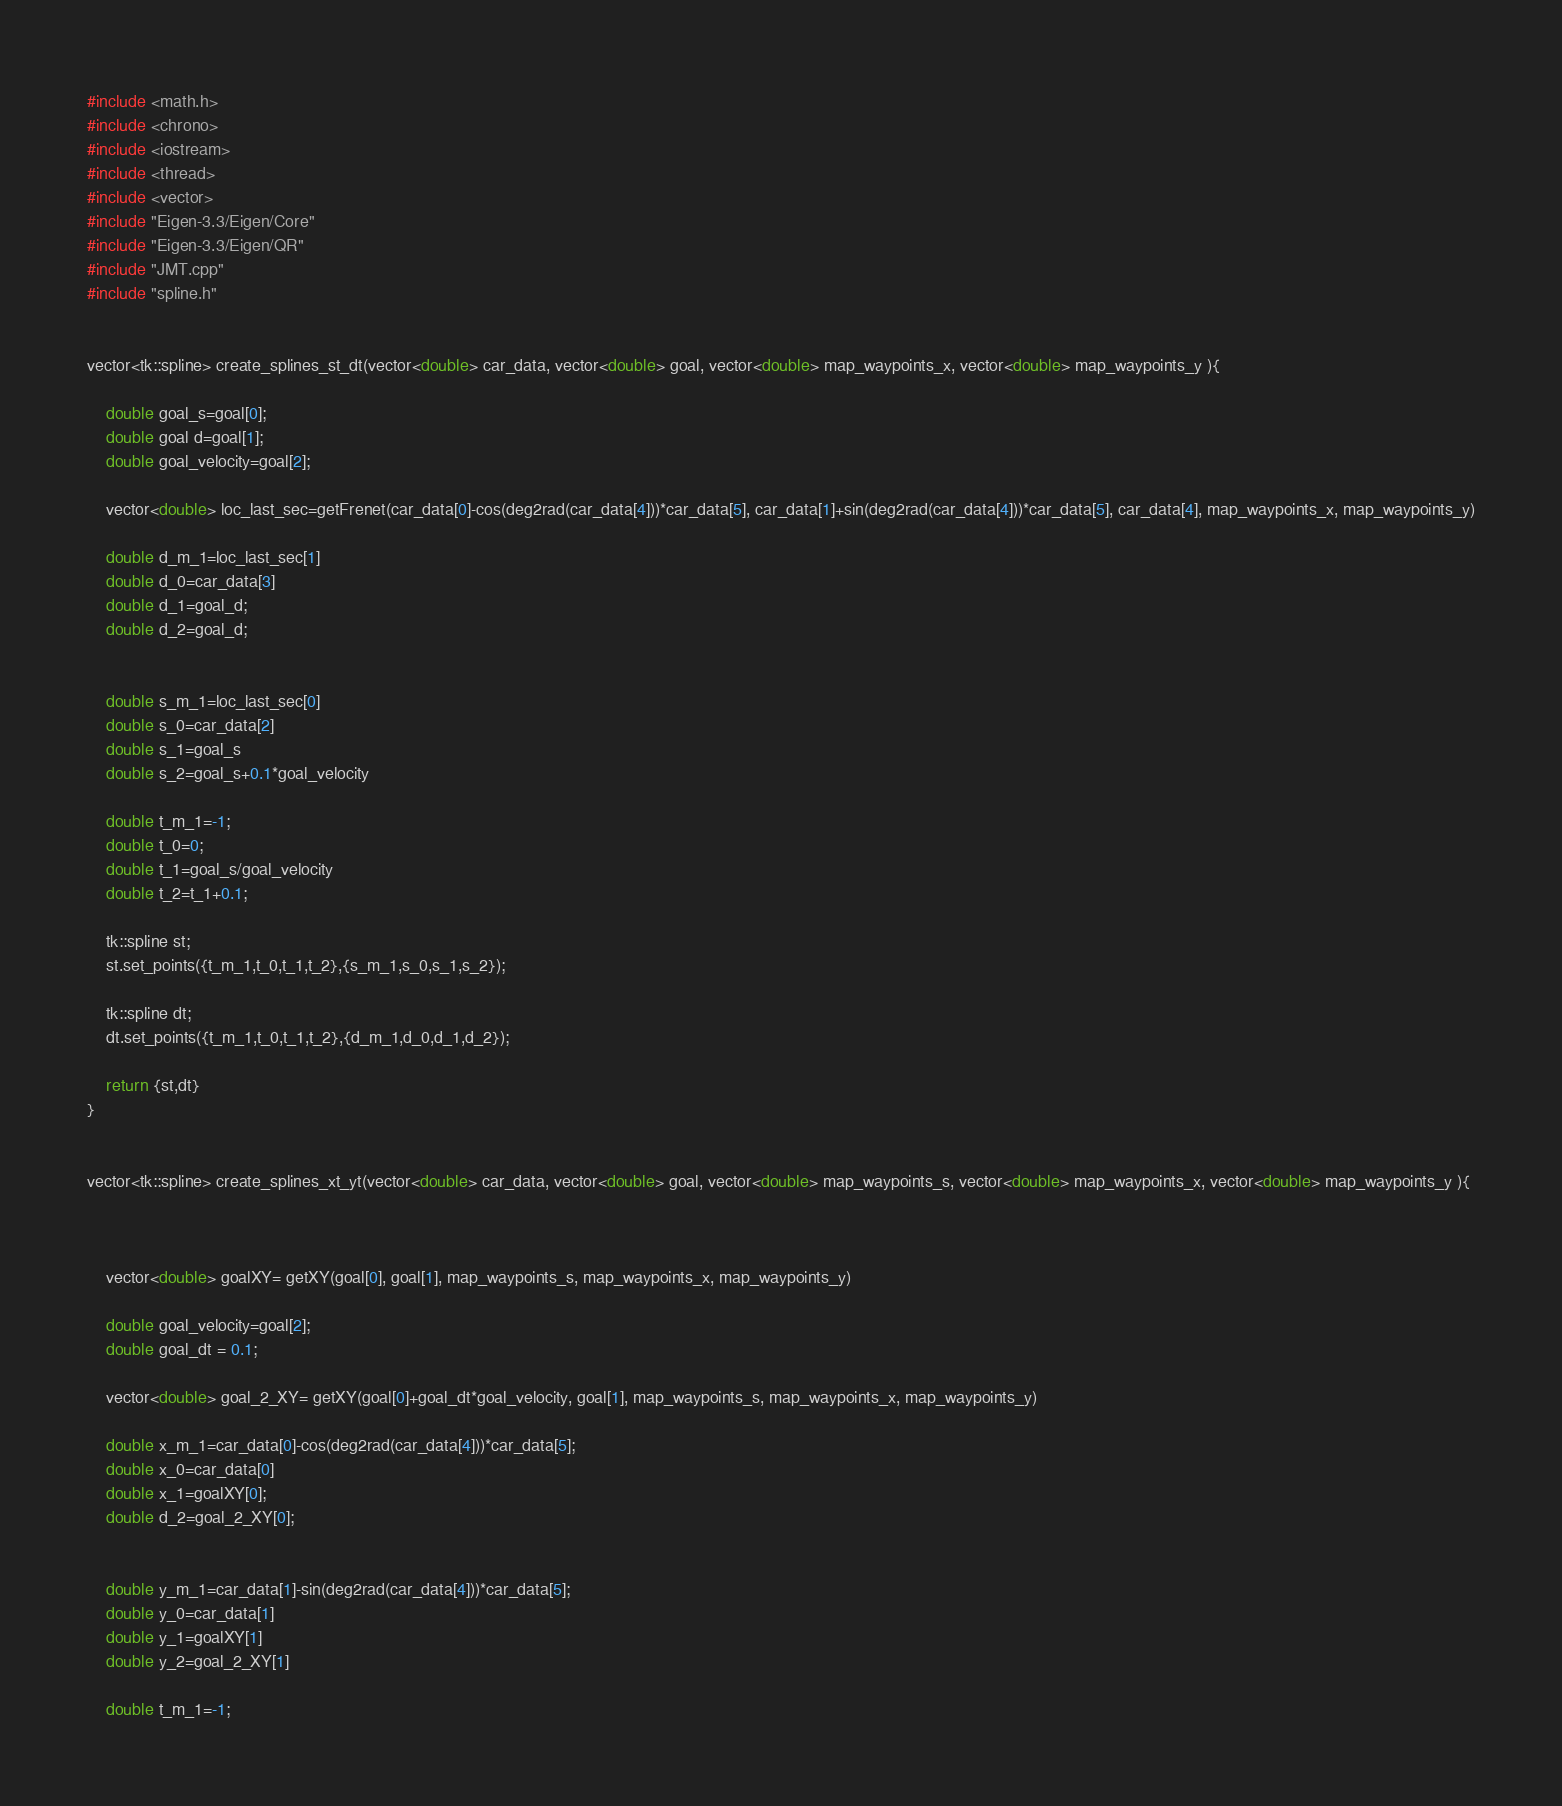<code> <loc_0><loc_0><loc_500><loc_500><_C++_>#include <math.h>
#include <chrono>
#include <iostream>
#include <thread>
#include <vector>
#include "Eigen-3.3/Eigen/Core"
#include "Eigen-3.3/Eigen/QR"
#include "JMT.cpp"
#include "spline.h"


vector<tk::spline> create_splines_st_dt(vector<double> car_data, vector<double> goal, vector<double> map_waypoints_x, vector<double> map_waypoints_y ){

    double goal_s=goal[0];
    double goal d=goal[1];
    double goal_velocity=goal[2];

    vector<double> loc_last_sec=getFrenet(car_data[0]-cos(deg2rad(car_data[4]))*car_data[5], car_data[1]+sin(deg2rad(car_data[4]))*car_data[5], car_data[4], map_waypoints_x, map_waypoints_y)

    double d_m_1=loc_last_sec[1]
    double d_0=car_data[3]
    double d_1=goal_d;
    double d_2=goal_d;


    double s_m_1=loc_last_sec[0]
    double s_0=car_data[2]
    double s_1=goal_s
    double s_2=goal_s+0.1*goal_velocity

    double t_m_1=-1;
    double t_0=0;
    double t_1=goal_s/goal_velocity
    double t_2=t_1+0.1;

    tk::spline st;
    st.set_points({t_m_1,t_0,t_1,t_2},{s_m_1,s_0,s_1,s_2});

    tk::spline dt;
    dt.set_points({t_m_1,t_0,t_1,t_2},{d_m_1,d_0,d_1,d_2});

    return {st,dt}
}


vector<tk::spline> create_splines_xt_yt(vector<double> car_data, vector<double> goal, vector<double> map_waypoints_s, vector<double> map_waypoints_x, vector<double> map_waypoints_y ){



    vector<double> goalXY= getXY(goal[0], goal[1], map_waypoints_s, map_waypoints_x, map_waypoints_y)

    double goal_velocity=goal[2];
    double goal_dt = 0.1;

    vector<double> goal_2_XY= getXY(goal[0]+goal_dt*goal_velocity, goal[1], map_waypoints_s, map_waypoints_x, map_waypoints_y)

    double x_m_1=car_data[0]-cos(deg2rad(car_data[4]))*car_data[5];
    double x_0=car_data[0]
    double x_1=goalXY[0];
    double d_2=goal_2_XY[0];


    double y_m_1=car_data[1]-sin(deg2rad(car_data[4]))*car_data[5];
    double y_0=car_data[1]
    double y_1=goalXY[1]
    double y_2=goal_2_XY[1]

    double t_m_1=-1;</code> 